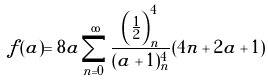<formula> <loc_0><loc_0><loc_500><loc_500>f ( a ) = 8 a \sum _ { n = 0 } ^ { \infty } \frac { \left ( \frac { 1 } { 2 } \right ) _ { n } ^ { 4 } } { ( a + 1 ) _ { n } ^ { 4 } } ( 4 n + 2 a + 1 )</formula> 